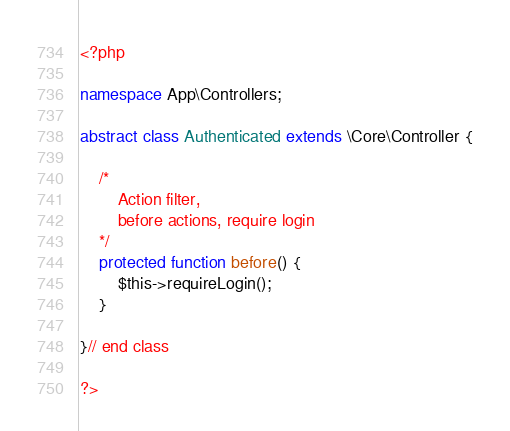Convert code to text. <code><loc_0><loc_0><loc_500><loc_500><_PHP_><?php

namespace App\Controllers;

abstract class Authenticated extends \Core\Controller {

    /*
        Action filter, 
        before actions, require login
    */
    protected function before() {
        $this->requireLogin();
    }
    
}// end class

?></code> 